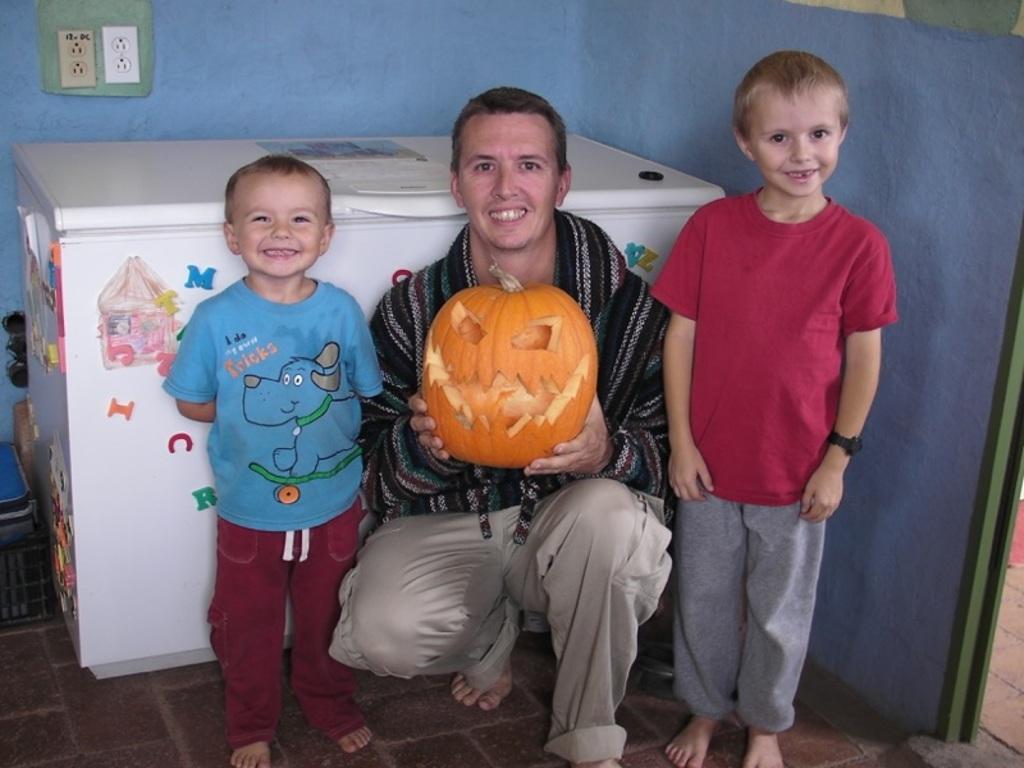Can you describe this image briefly? In the center of the image we can see two kids and one person smiling, which we can see on their faces. And the man is holding a pumpkin. In the background there is a wall, switchboard, refrigerator and a few other objects. And we can see some decorative stickers on the refrigerator. 